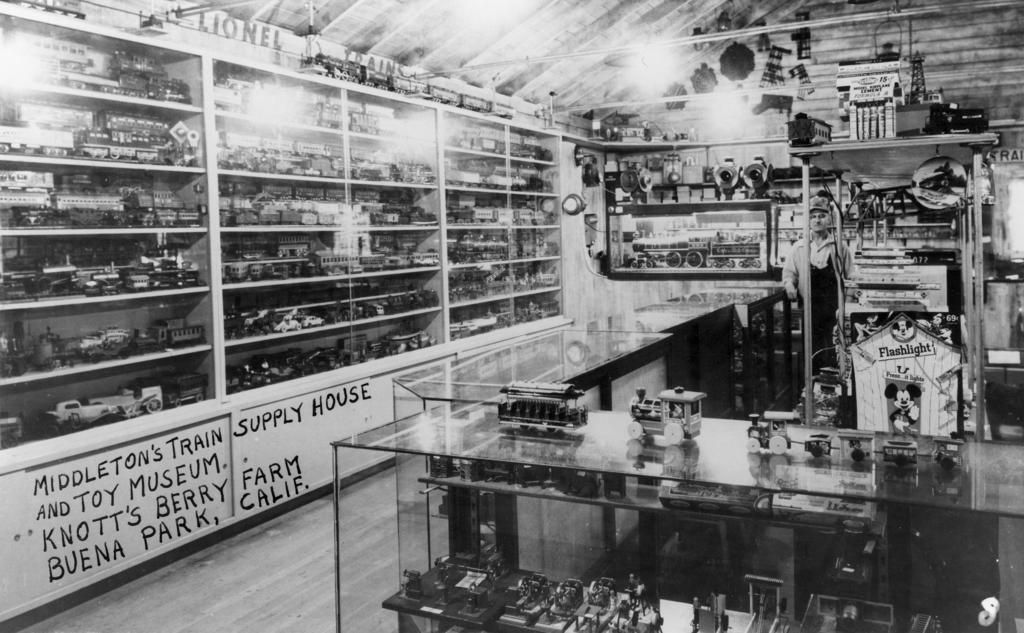<image>
Offer a succinct explanation of the picture presented. a black and white interior of a shop with sign reading Middleton's Train and Toy Museum 